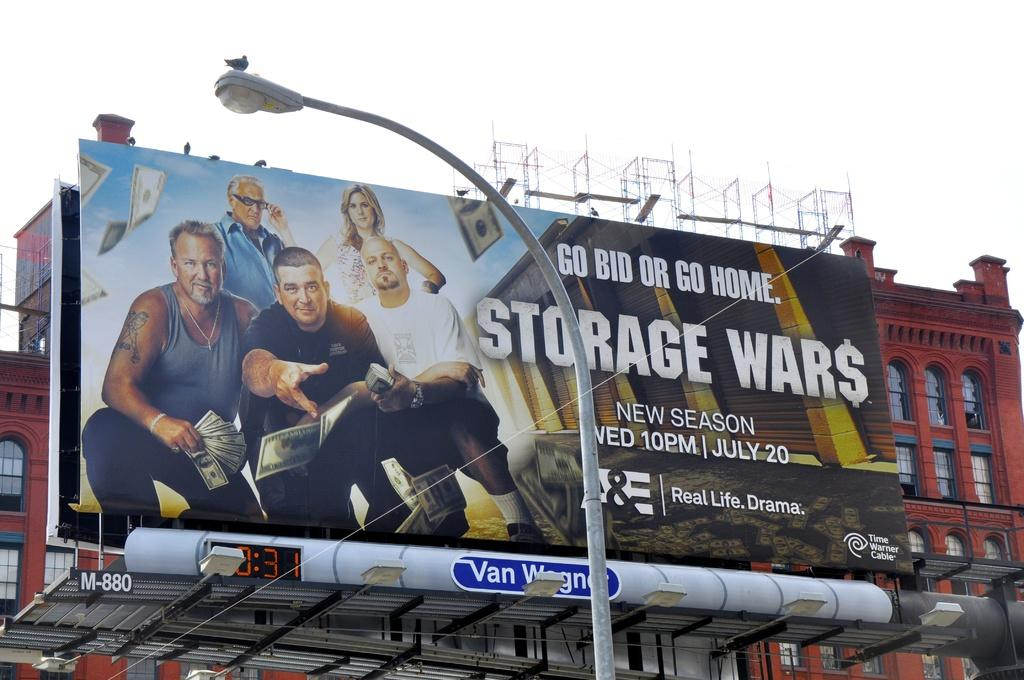<image>
Describe the image concisely. A billboard promoting the tv show Storage Wars. 